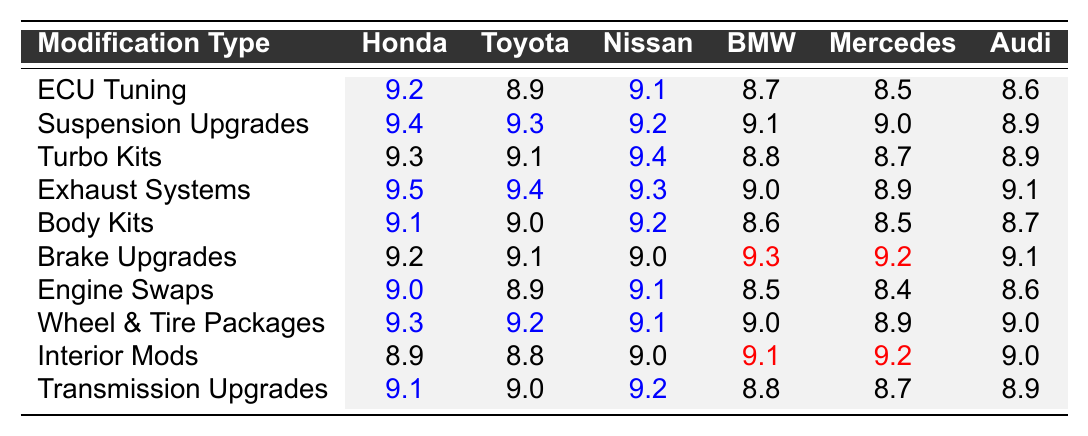What is the satisfaction rating for Suspension Upgrades on Honda cars? The table shows that the satisfaction rating for Suspension Upgrades on Honda cars is 9.4.
Answer: 9.4 Which modification type has the highest rating for Toyota? By checking the values for Toyota across all modifications, the highest rating is seen in Suspension Upgrades at 9.3.
Answer: 9.3 Is the average satisfaction rating for Nissan modifications higher than 9.0? The values for Nissan modifications are 9.4, 9.2, 9.1, 9.3, 9.2, 9.0, 9.1, and the average can be calculated as (9.4 + 9.2 + 9.1 + 9.3 + 9.2 + 9.0 + 9.1) / 7 = 9.1, which is higher than 9.0.
Answer: Yes What is the difference in satisfaction rating between the Exhaust Systems for Honda and BMW? For Honda, the rating is 9.5 and for BMW, it is 9.0. The difference is 9.5 - 9.0 = 0.5.
Answer: 0.5 Which car brand has the lowest satisfaction rating for Body Kits? The table shows that Mercedes has the lowest rating for Body Kits at 8.5.
Answer: Mercedes What is the average satisfaction rating for Turbo Kits among German brands (BMW, Mercedes, Audi)? The ratings for Turbo Kits are 8.8 for BMW, 8.7 for Mercedes, and 8.9 for Audi. The average is (8.8 + 8.7 + 8.9) / 3 = 8.8.
Answer: 8.8 Which modification type shows the largest difference in satisfaction rating between Honda and Mercedes? We check the ratings for each modification type: the largest difference occurs for Exhaust Systems, where Honda has 9.5 and Mercedes has 8.9, which is a difference of 0.6.
Answer: 0.6 Is there a modification type where Nissan has a higher satisfaction rating than BMW? Comparing the ratings, Nissan is higher than BMW in ECU Tuning (9.1 vs 8.7), Suspension Upgrades (9.2 vs 9.1), and Turbo Kits (9.4 vs 8.8).
Answer: Yes What is the highest satisfaction rating for any modification type in the table? The highest satisfaction rating listed is 9.5 for Honda regarding Exhaust Systems.
Answer: 9.5 For which modification does Audi have the closest rating to that of Toyota? Comparing Audi's and Toyota's ratings, Wheel & Tire Packages shows them both rating 9.0, which is the closest.
Answer: Wheel & Tire Packages 